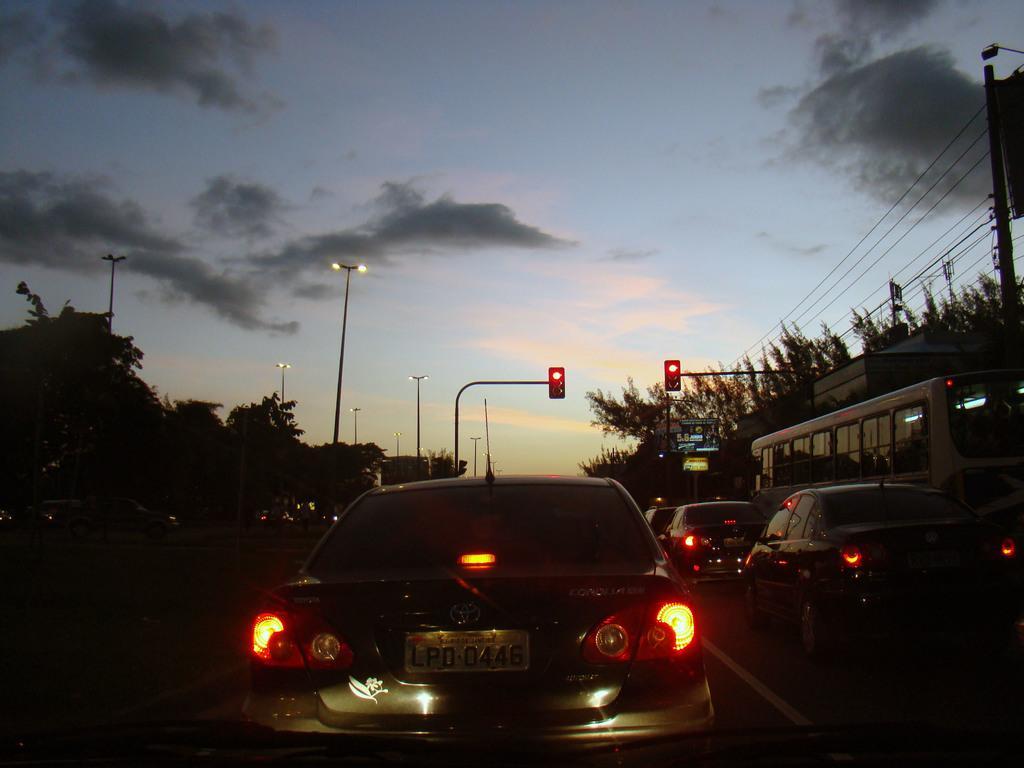Please provide a concise description of this image. We can see cars and bus on the road. Background we can see lights and traffic signals on poles and we can see sky. 